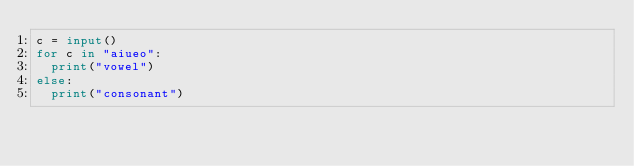<code> <loc_0><loc_0><loc_500><loc_500><_Python_>c = input()
for c in "aiueo":
  print("vowel")
else:
  print("consonant")
</code> 